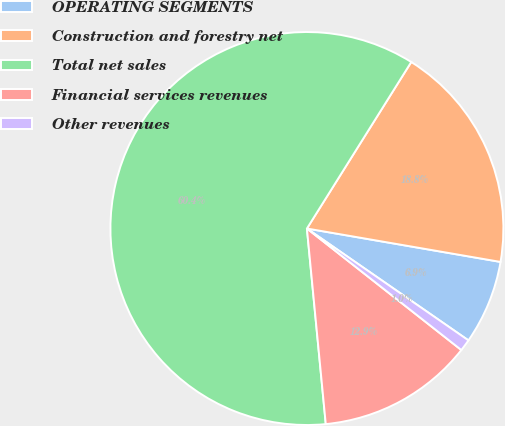Convert chart to OTSL. <chart><loc_0><loc_0><loc_500><loc_500><pie_chart><fcel>OPERATING SEGMENTS<fcel>Construction and forestry net<fcel>Total net sales<fcel>Financial services revenues<fcel>Other revenues<nl><fcel>6.92%<fcel>18.81%<fcel>60.44%<fcel>12.86%<fcel>0.97%<nl></chart> 